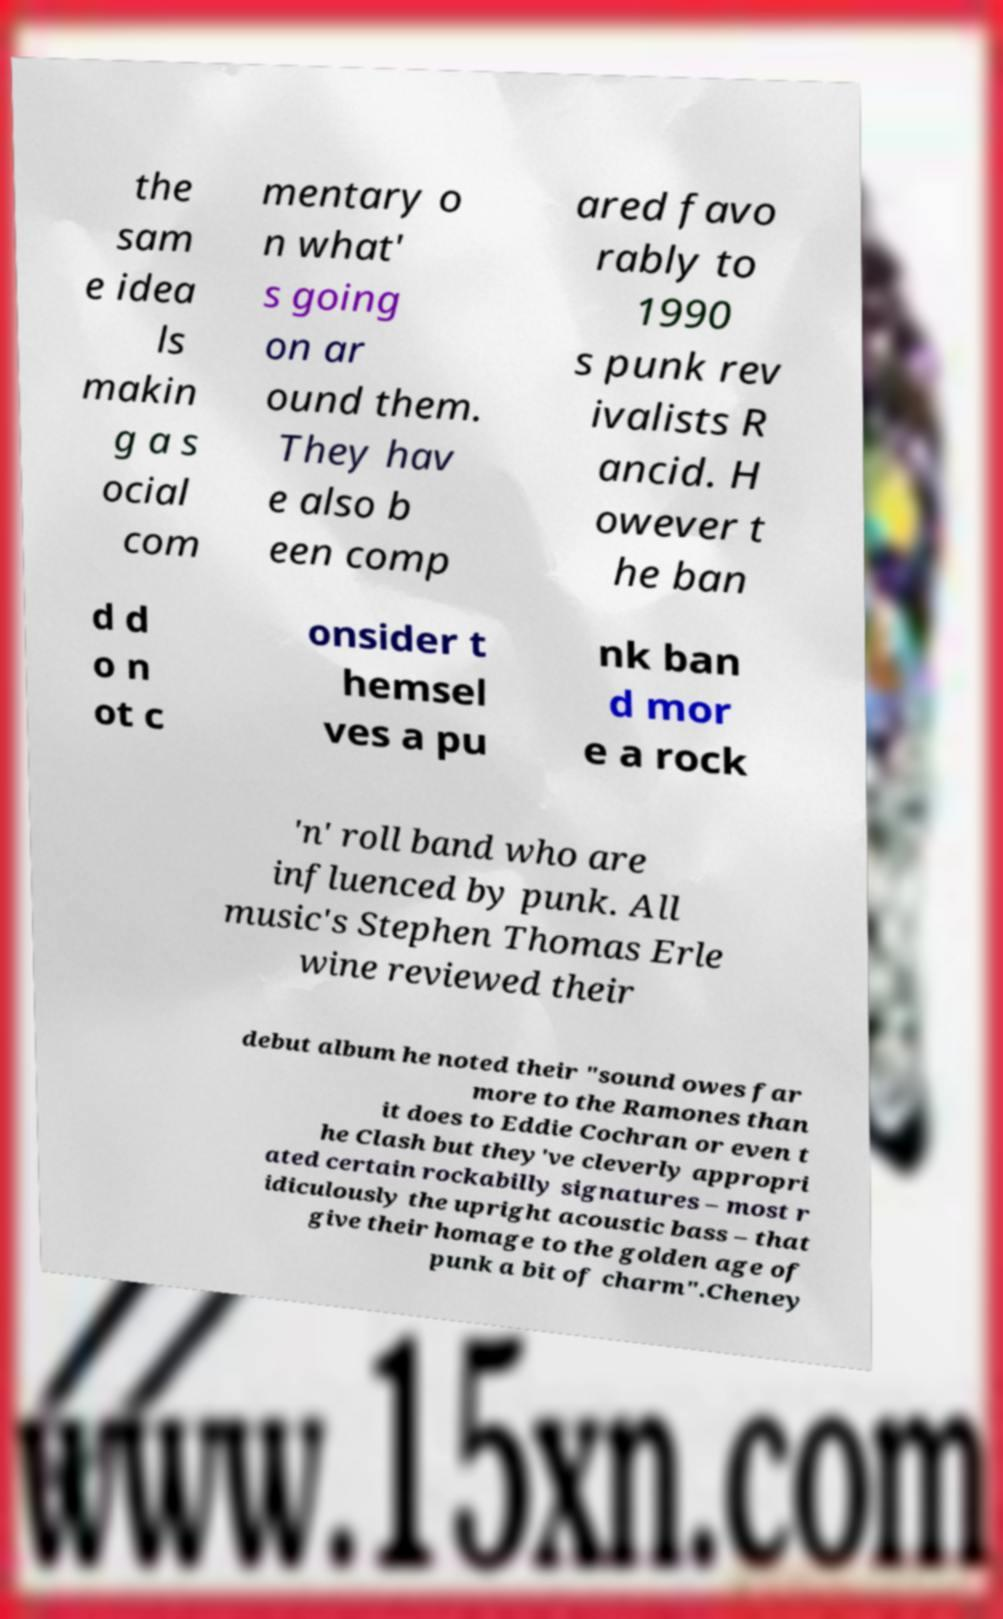Please identify and transcribe the text found in this image. the sam e idea ls makin g a s ocial com mentary o n what' s going on ar ound them. They hav e also b een comp ared favo rably to 1990 s punk rev ivalists R ancid. H owever t he ban d d o n ot c onsider t hemsel ves a pu nk ban d mor e a rock 'n' roll band who are influenced by punk. All music's Stephen Thomas Erle wine reviewed their debut album he noted their "sound owes far more to the Ramones than it does to Eddie Cochran or even t he Clash but they've cleverly appropri ated certain rockabilly signatures – most r idiculously the upright acoustic bass – that give their homage to the golden age of punk a bit of charm".Cheney 